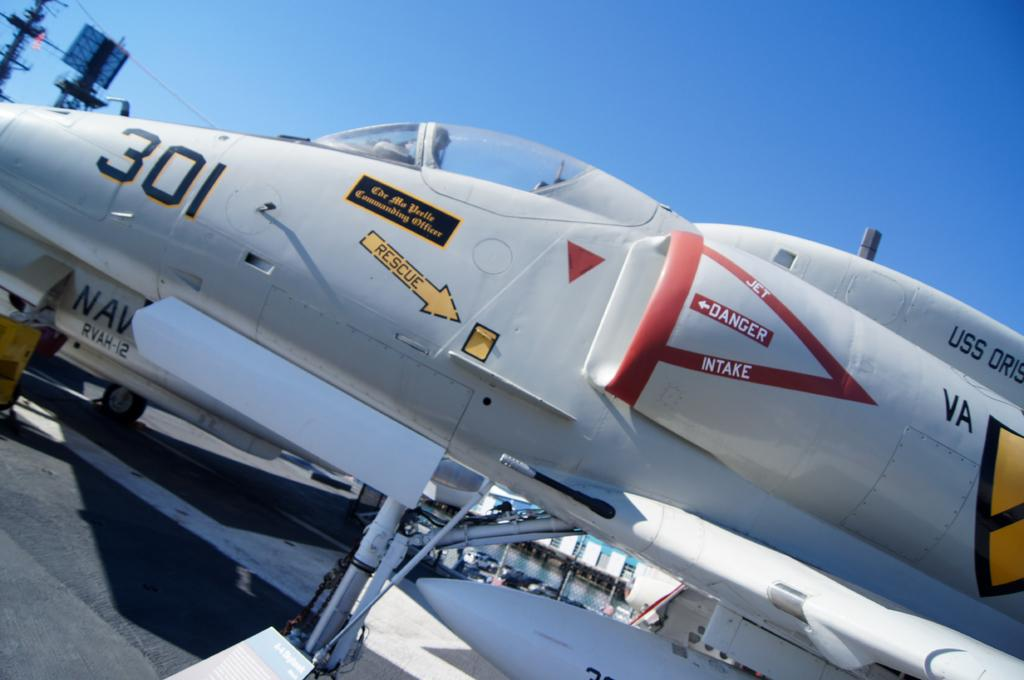What is the main subject in the center of the image? There is an aircraft in the center of the image. What can be seen at the top of the image? The sky is visible at the top of the image. What is located at the bottom of the image? There is a road at the bottom of the image. Where is the sofa located in the image? There is no sofa present in the image. What type of vest is being worn by the aircraft in the image? Aircrafts do not wear vests, as they are inanimate objects. 